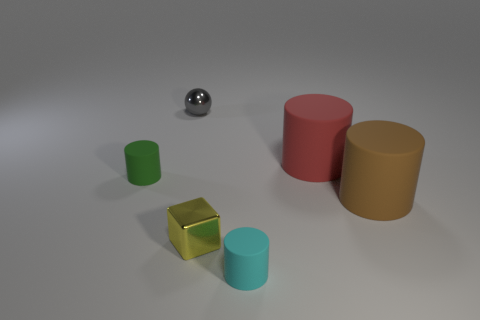How many other objects are the same material as the tiny green cylinder?
Your answer should be very brief. 3. What number of brown rubber things have the same size as the red rubber cylinder?
Give a very brief answer. 1. What color is the ball that is the same material as the tiny yellow thing?
Offer a terse response. Gray. Are there more large purple metallic blocks than small cyan matte cylinders?
Give a very brief answer. No. Does the big brown thing have the same material as the small gray ball?
Your response must be concise. No. There is a large brown object that is made of the same material as the red cylinder; what shape is it?
Your response must be concise. Cylinder. Is the number of large red metal things less than the number of small gray metal balls?
Offer a terse response. Yes. What is the tiny object that is both in front of the gray metal object and to the left of the yellow thing made of?
Keep it short and to the point. Rubber. What size is the shiny object behind the large thing that is behind the small matte cylinder to the left of the block?
Your answer should be very brief. Small. There is a tiny cyan object; is it the same shape as the thing to the right of the large red rubber cylinder?
Offer a very short reply. Yes. 